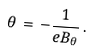<formula> <loc_0><loc_0><loc_500><loc_500>\theta \, = \, - \frac { 1 } { e B _ { \theta } } \, .</formula> 